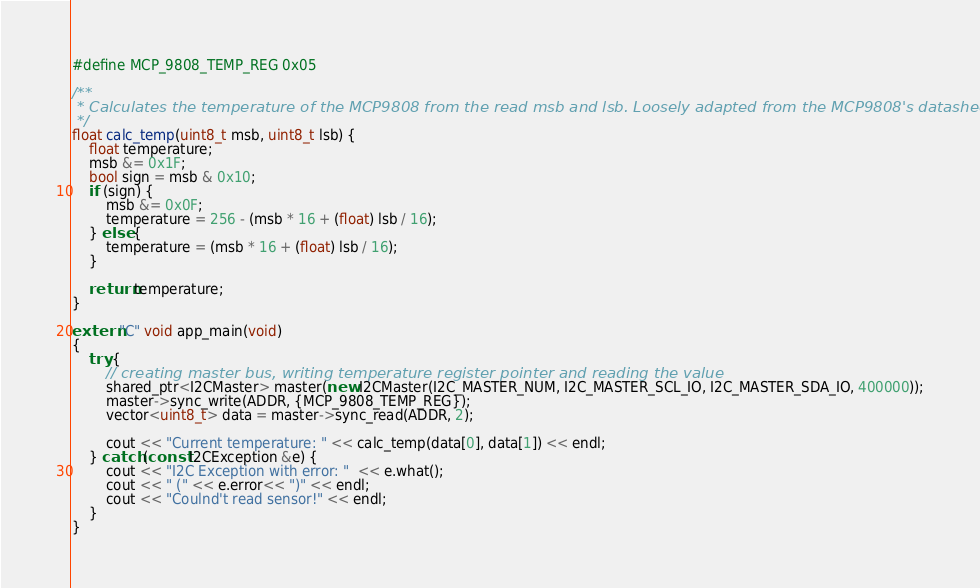Convert code to text. <code><loc_0><loc_0><loc_500><loc_500><_C++_>
#define MCP_9808_TEMP_REG 0x05

/**
 * Calculates the temperature of the MCP9808 from the read msb and lsb. Loosely adapted from the MCP9808's datasheet.
 */
float calc_temp(uint8_t msb, uint8_t lsb) {
    float temperature;
    msb &= 0x1F;
    bool sign = msb & 0x10;
    if (sign) {
        msb &= 0x0F;
        temperature = 256 - (msb * 16 + (float) lsb / 16);
    } else {
        temperature = (msb * 16 + (float) lsb / 16);
    }

    return temperature;
}

extern "C" void app_main(void)
{
    try {
        // creating master bus, writing temperature register pointer and reading the value
        shared_ptr<I2CMaster> master(new I2CMaster(I2C_MASTER_NUM, I2C_MASTER_SCL_IO, I2C_MASTER_SDA_IO, 400000));
        master->sync_write(ADDR, {MCP_9808_TEMP_REG});
        vector<uint8_t> data = master->sync_read(ADDR, 2);

        cout << "Current temperature: " << calc_temp(data[0], data[1]) << endl;
    } catch (const I2CException &e) {
        cout << "I2C Exception with error: "  << e.what();
        cout << " (" << e.error<< ")" << endl;
        cout << "Coulnd't read sensor!" << endl;
    }
}
</code> 